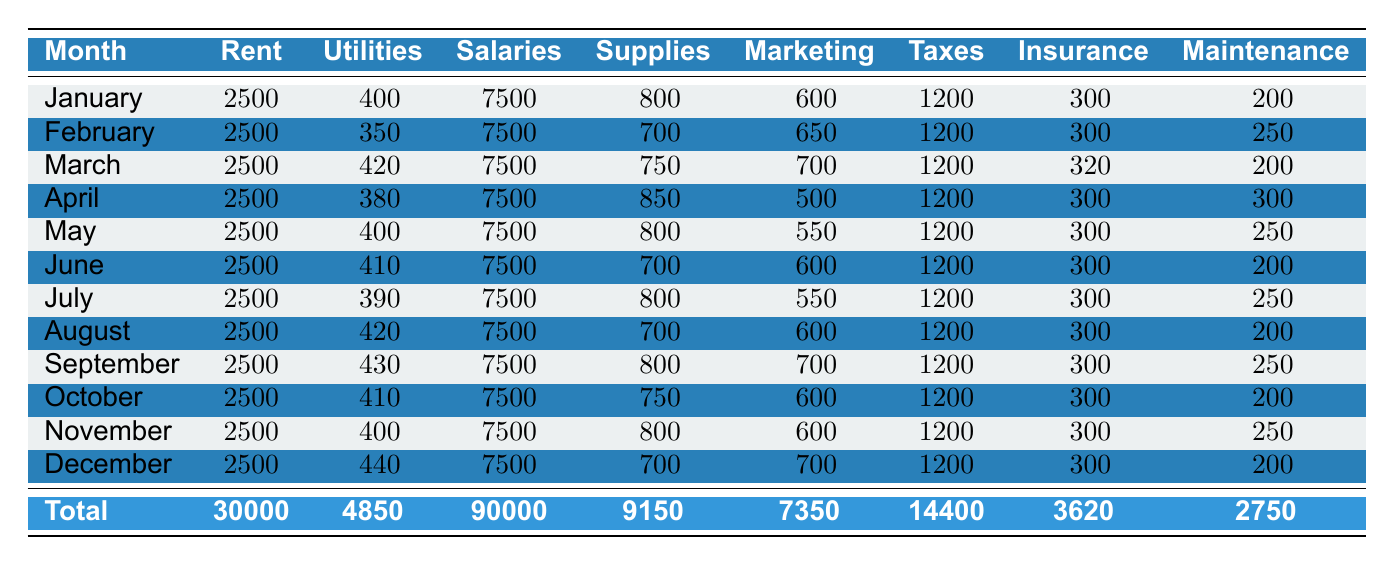What is the total expense on utilities for the year? To find the total expense on utilities, we need to sum up the utilities expenses for each month. From the table, the monthly utilities expenses are: January (400), February (350), March (420), April (380), May (400), June (410), July (390), August (420), September (430), October (410), November (400), December (440). Adding these gives: 400 + 350 + 420 + 380 + 400 + 410 + 390 + 420 + 430 + 410 + 400 + 440 = 4850.
Answer: 4850 In which month was the highest maintenance expense recorded? Looking at the maintenance expenses for each month, the values are: January (200), February (250), March (200), April (300), May (250), June (200), July (250), August (200), September (250), October (200), November (250), December (200). The highest value is in April (300).
Answer: April What was the average marketing expense per month? To calculate the average marketing expense, we first sum each month's marketing expenses: January (600), February (650), March (700), April (500), May (550), June (600), July (550), August (600), September (700), October (600), November (600), December (700). The total is 7350. There are 12 months, so the average is calculated as 7350 / 12 = 612.5.
Answer: 612.5 Did the total expenses for salaries exceed 70,000 throughout the year? The total salaries expense is constant at 7500 each month. Multiplying this by 12 months gives us 7500 * 12 = 90000. Therefore, it did exceed 70,000.
Answer: Yes Which category had the lowest total expense for the year? We need to sum all the expenses for each category. Total expenses are: Rent (30000), Utilities (4850), Salaries (90000), Supplies (9150), Marketing (7350), Taxes (14400), Insurance (3620), Maintenance (2750). The lowest total is for Maintenance at 2750.
Answer: Maintenance 